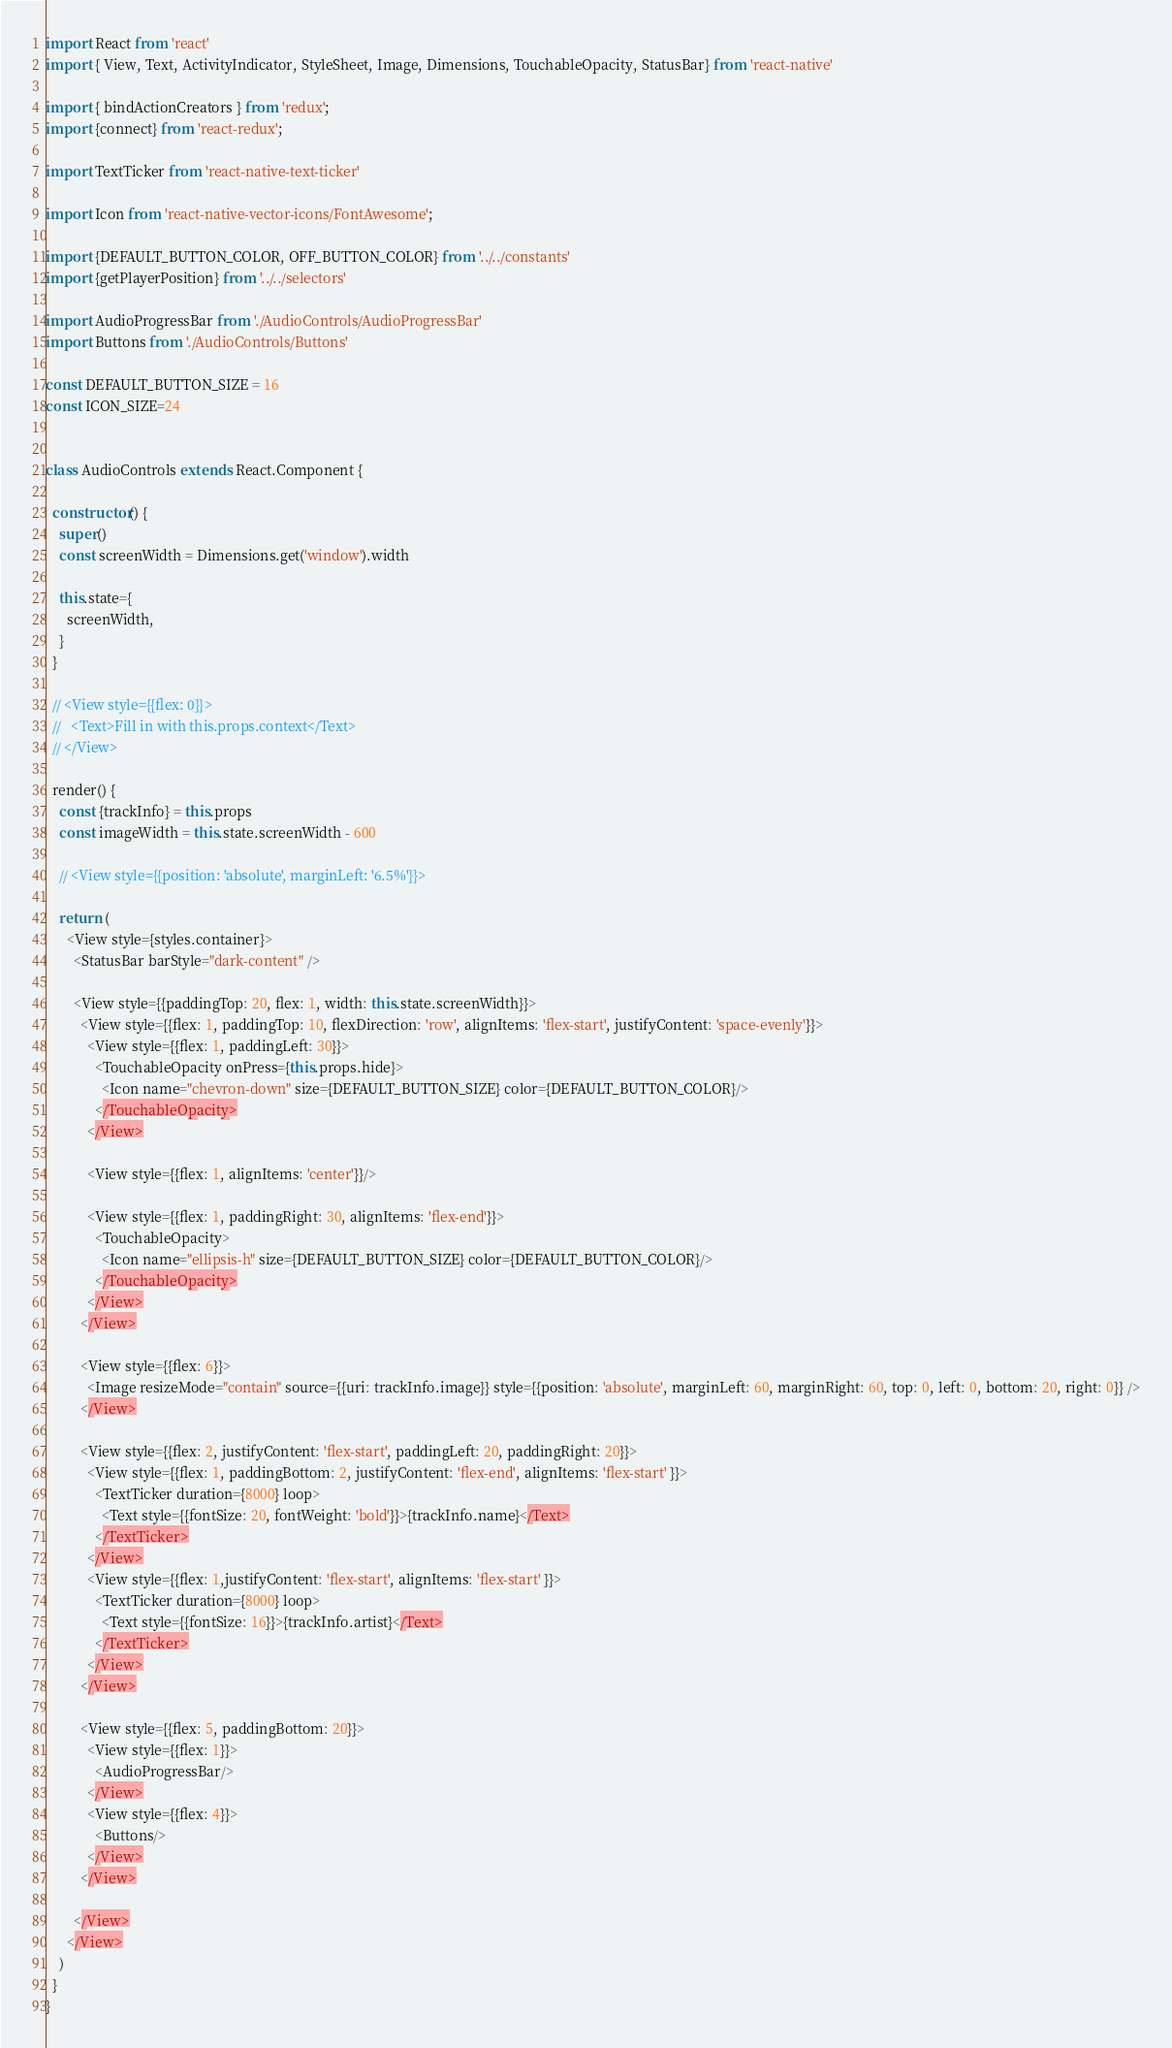<code> <loc_0><loc_0><loc_500><loc_500><_JavaScript_>import React from 'react'
import { View, Text, ActivityIndicator, StyleSheet, Image, Dimensions, TouchableOpacity, StatusBar} from 'react-native'

import { bindActionCreators } from 'redux';
import {connect} from 'react-redux';

import TextTicker from 'react-native-text-ticker'

import Icon from 'react-native-vector-icons/FontAwesome';

import {DEFAULT_BUTTON_COLOR, OFF_BUTTON_COLOR} from '../../constants'
import {getPlayerPosition} from '../../selectors'

import AudioProgressBar from './AudioControls/AudioProgressBar'
import Buttons from './AudioControls/Buttons'

const DEFAULT_BUTTON_SIZE = 16
const ICON_SIZE=24


class AudioControls extends React.Component {

  constructor() {
    super()
    const screenWidth = Dimensions.get('window').width

    this.state={
      screenWidth,
    }
  }

  // <View style={{flex: 0}}>
  //   <Text>Fill in with this.props.context</Text>
  // </View>

  render() {
    const {trackInfo} = this.props
    const imageWidth = this.state.screenWidth - 600

    // <View style={{position: 'absolute', marginLeft: '6.5%'}}>

    return (
      <View style={styles.container}>
        <StatusBar barStyle="dark-content" />

        <View style={{paddingTop: 20, flex: 1, width: this.state.screenWidth}}>
          <View style={{flex: 1, paddingTop: 10, flexDirection: 'row', alignItems: 'flex-start', justifyContent: 'space-evenly'}}>
            <View style={{flex: 1, paddingLeft: 30}}>
              <TouchableOpacity onPress={this.props.hide}>
                <Icon name="chevron-down" size={DEFAULT_BUTTON_SIZE} color={DEFAULT_BUTTON_COLOR}/>
              </TouchableOpacity>
            </View>

            <View style={{flex: 1, alignItems: 'center'}}/>

            <View style={{flex: 1, paddingRight: 30, alignItems: 'flex-end'}}>
              <TouchableOpacity>
                <Icon name="ellipsis-h" size={DEFAULT_BUTTON_SIZE} color={DEFAULT_BUTTON_COLOR}/>
              </TouchableOpacity>
            </View>
          </View>

          <View style={{flex: 6}}>
            <Image resizeMode="contain" source={{uri: trackInfo.image}} style={{position: 'absolute', marginLeft: 60, marginRight: 60, top: 0, left: 0, bottom: 20, right: 0}} />
          </View>

          <View style={{flex: 2, justifyContent: 'flex-start', paddingLeft: 20, paddingRight: 20}}>
            <View style={{flex: 1, paddingBottom: 2, justifyContent: 'flex-end', alignItems: 'flex-start' }}>
              <TextTicker duration={8000} loop>
                <Text style={{fontSize: 20, fontWeight: 'bold'}}>{trackInfo.name}</Text>
              </TextTicker>
            </View>
            <View style={{flex: 1,justifyContent: 'flex-start', alignItems: 'flex-start' }}>
              <TextTicker duration={8000} loop>
                <Text style={{fontSize: 16}}>{trackInfo.artist}</Text>
              </TextTicker>
            </View>
          </View>

          <View style={{flex: 5, paddingBottom: 20}}>
            <View style={{flex: 1}}>
              <AudioProgressBar/>
            </View>
            <View style={{flex: 4}}>
              <Buttons/>
            </View>
          </View>

        </View>
      </View>
    )
  }
}
</code> 